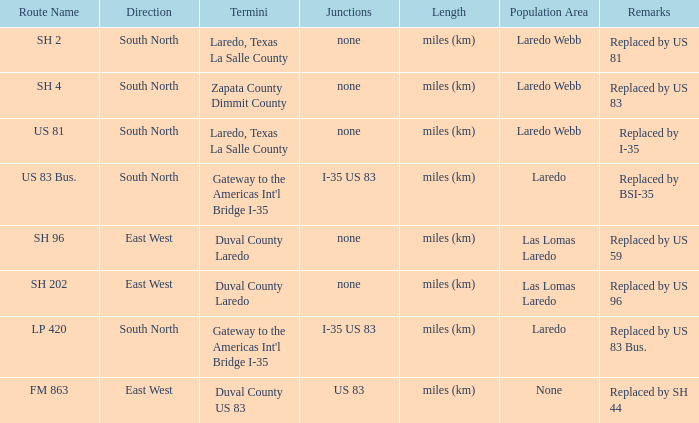Could you parse the entire table as a dict? {'header': ['Route Name', 'Direction', 'Termini', 'Junctions', 'Length', 'Population Area', 'Remarks'], 'rows': [['SH 2', 'South North', 'Laredo, Texas La Salle County', 'none', 'miles (km)', 'Laredo Webb', 'Replaced by US 81'], ['SH 4', 'South North', 'Zapata County Dimmit County', 'none', 'miles (km)', 'Laredo Webb', 'Replaced by US 83'], ['US 81', 'South North', 'Laredo, Texas La Salle County', 'none', 'miles (km)', 'Laredo Webb', 'Replaced by I-35'], ['US 83 Bus.', 'South North', "Gateway to the Americas Int'l Bridge I-35", 'I-35 US 83', 'miles (km)', 'Laredo', 'Replaced by BSI-35'], ['SH 96', 'East West', 'Duval County Laredo', 'none', 'miles (km)', 'Las Lomas Laredo', 'Replaced by US 59'], ['SH 202', 'East West', 'Duval County Laredo', 'none', 'miles (km)', 'Las Lomas Laredo', 'Replaced by US 96'], ['LP 420', 'South North', "Gateway to the Americas Int'l Bridge I-35", 'I-35 US 83', 'miles (km)', 'Laredo', 'Replaced by US 83 Bus.'], ['FM 863', 'East West', 'Duval County US 83', 'US 83', 'miles (km)', 'None', 'Replaced by SH 44']]} Which population areas have "replaced by us 83" listed in their remarks section? Laredo Webb. 